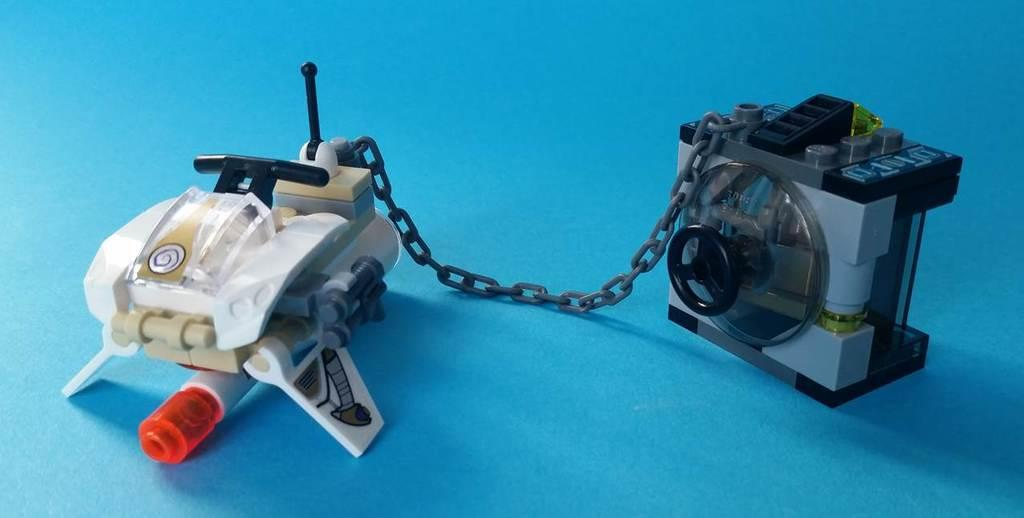How many toys are present in the image? There are 2 toys in the image. What colors can be seen on the toys? The toys are of white, cream, red, grey, and black colors. What is the color of the surface on which the toys are placed? The toys are on a blue color surface. What type of plot is being discussed in the image? There is no plot present in the image, as it features toys on a surface. 